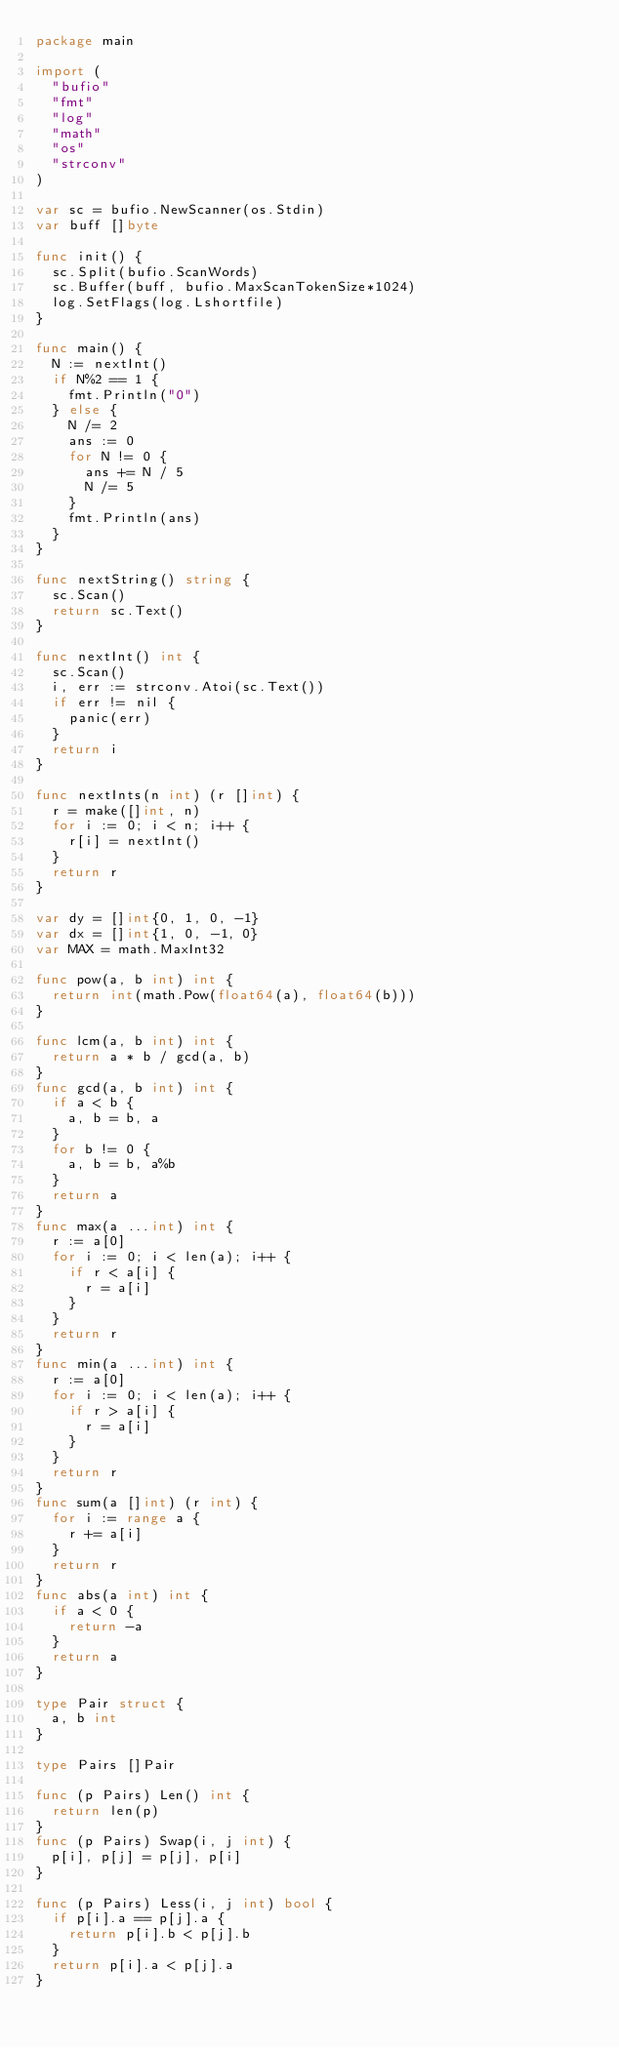<code> <loc_0><loc_0><loc_500><loc_500><_Go_>package main

import (
	"bufio"
	"fmt"
	"log"
	"math"
	"os"
	"strconv"
)

var sc = bufio.NewScanner(os.Stdin)
var buff []byte

func init() {
	sc.Split(bufio.ScanWords)
	sc.Buffer(buff, bufio.MaxScanTokenSize*1024)
	log.SetFlags(log.Lshortfile)
}

func main() {
	N := nextInt()
	if N%2 == 1 {
		fmt.Println("0")
	} else {
		N /= 2
		ans := 0
		for N != 0 {
			ans += N / 5
			N /= 5
		}
		fmt.Println(ans)
	}
}

func nextString() string {
	sc.Scan()
	return sc.Text()
}

func nextInt() int {
	sc.Scan()
	i, err := strconv.Atoi(sc.Text())
	if err != nil {
		panic(err)
	}
	return i
}

func nextInts(n int) (r []int) {
	r = make([]int, n)
	for i := 0; i < n; i++ {
		r[i] = nextInt()
	}
	return r
}

var dy = []int{0, 1, 0, -1}
var dx = []int{1, 0, -1, 0}
var MAX = math.MaxInt32

func pow(a, b int) int {
	return int(math.Pow(float64(a), float64(b)))
}

func lcm(a, b int) int {
	return a * b / gcd(a, b)
}
func gcd(a, b int) int {
	if a < b {
		a, b = b, a
	}
	for b != 0 {
		a, b = b, a%b
	}
	return a
}
func max(a ...int) int {
	r := a[0]
	for i := 0; i < len(a); i++ {
		if r < a[i] {
			r = a[i]
		}
	}
	return r
}
func min(a ...int) int {
	r := a[0]
	for i := 0; i < len(a); i++ {
		if r > a[i] {
			r = a[i]
		}
	}
	return r
}
func sum(a []int) (r int) {
	for i := range a {
		r += a[i]
	}
	return r
}
func abs(a int) int {
	if a < 0 {
		return -a
	}
	return a
}

type Pair struct {
	a, b int
}

type Pairs []Pair

func (p Pairs) Len() int {
	return len(p)
}
func (p Pairs) Swap(i, j int) {
	p[i], p[j] = p[j], p[i]
}

func (p Pairs) Less(i, j int) bool {
	if p[i].a == p[j].a {
		return p[i].b < p[j].b
	}
	return p[i].a < p[j].a
}
</code> 